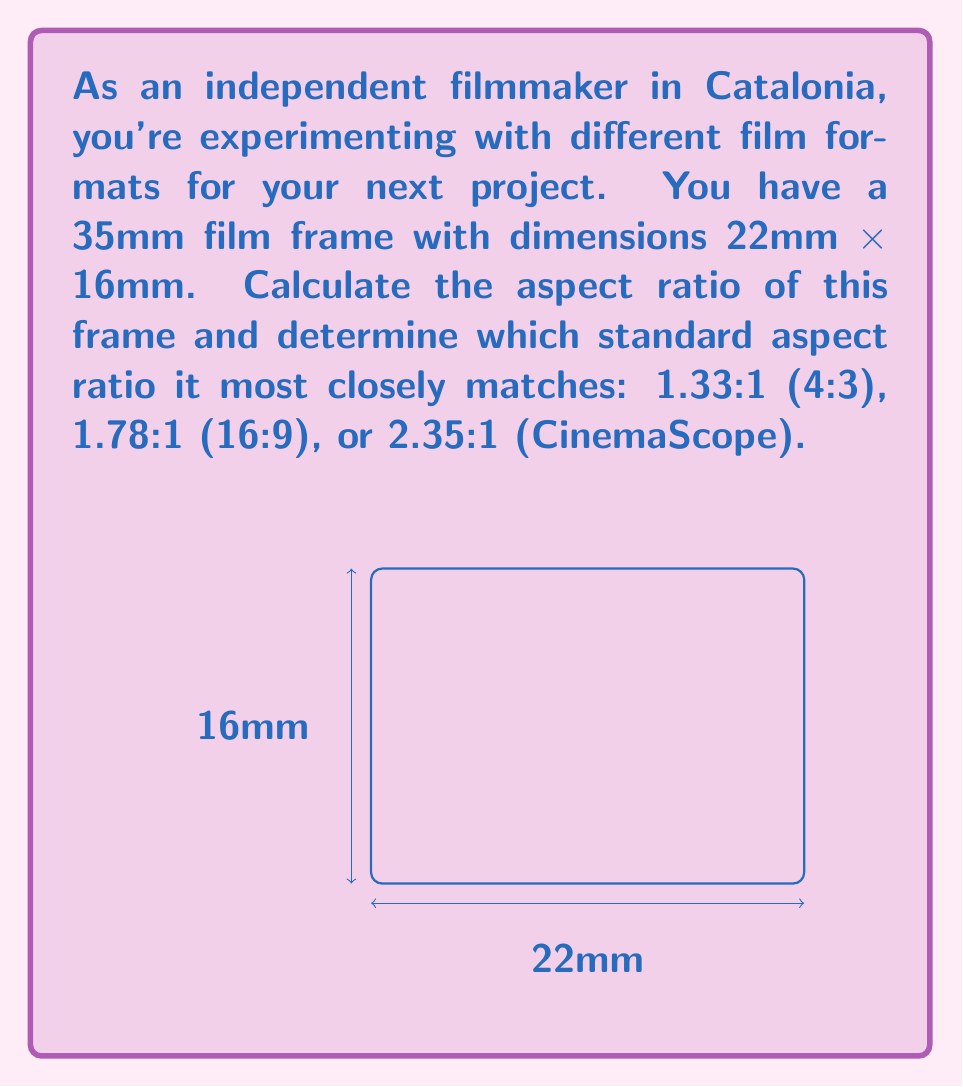Can you answer this question? To solve this problem, we'll follow these steps:

1) The aspect ratio is calculated by dividing the width by the height of the frame.

   Aspect Ratio = Width / Height

2) For the given 35mm film frame:
   Width = 22mm
   Height = 16mm

3) Calculate the aspect ratio:
   
   $$\text{Aspect Ratio} = \frac{22\text{mm}}{16\text{mm}} = 1.375$$

4) To express this as a ratio to 1, we divide both numerator and denominator by the denominator:

   $$1.375:1$$

5) Now, let's compare this to the given standard aspect ratios:
   - 1.33:1 (4:3)   : Difference = |1.375 - 1.33| = 0.045
   - 1.78:1 (16:9)  : Difference = |1.375 - 1.78| = 0.405
   - 2.35:1 (CinemaScope) : Difference = |1.375 - 2.35| = 0.975

6) The smallest difference is 0.045, corresponding to the 1.33:1 (4:3) aspect ratio.

Therefore, the calculated aspect ratio of 1.375:1 most closely matches the standard 4:3 (1.33:1) aspect ratio.
Answer: 1.375:1, closest to 4:3 (1.33:1) 